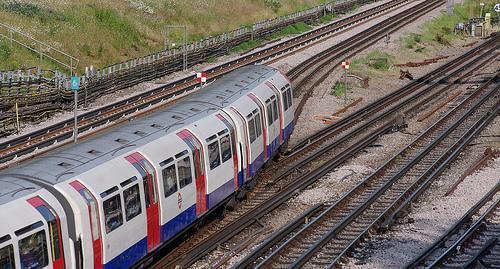How many trains are there?
Give a very brief answer. 1. 